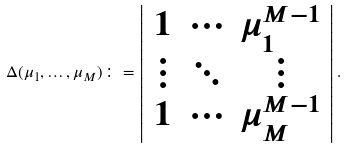<formula> <loc_0><loc_0><loc_500><loc_500>\Delta ( \mu _ { 1 } , \dots , \mu _ { M } ) \colon = \left | \begin{array} { c c c } 1 & \cdots & \mu _ { 1 } ^ { M - 1 } \\ \vdots & \ddots & \vdots \\ 1 & \cdots & \mu _ { M } ^ { M - 1 } \end{array} \right | .</formula> 